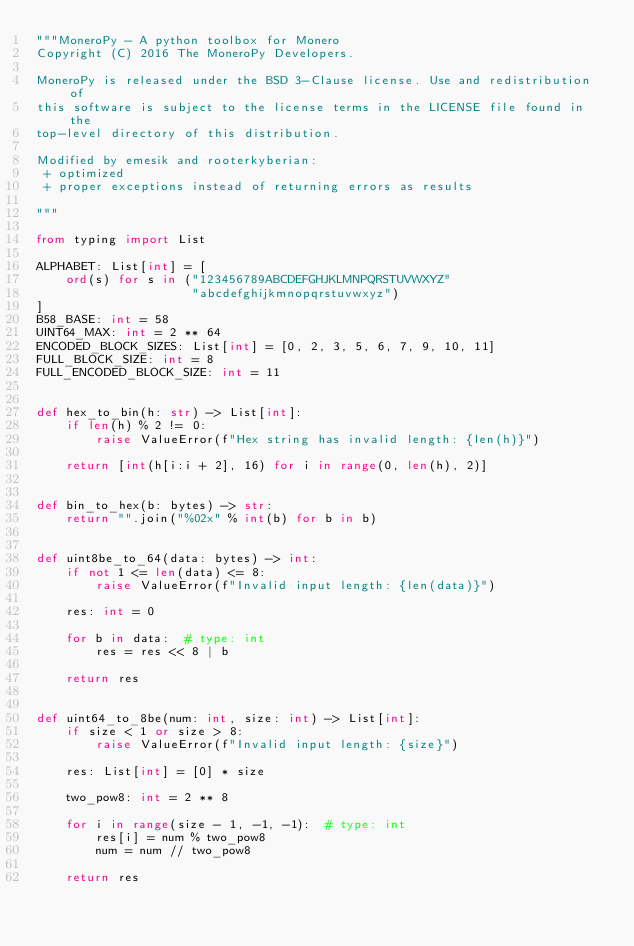<code> <loc_0><loc_0><loc_500><loc_500><_Python_>"""MoneroPy - A python toolbox for Monero
Copyright (C) 2016 The MoneroPy Developers.

MoneroPy is released under the BSD 3-Clause license. Use and redistribution of
this software is subject to the license terms in the LICENSE file found in the
top-level directory of this distribution.

Modified by emesik and rooterkyberian:
 + optimized
 + proper exceptions instead of returning errors as results

"""

from typing import List

ALPHABET: List[int] = [
    ord(s) for s in ("123456789ABCDEFGHJKLMNPQRSTUVWXYZ"
                     "abcdefghijkmnopqrstuvwxyz")
]
B58_BASE: int = 58
UINT64_MAX: int = 2 ** 64
ENCODED_BLOCK_SIZES: List[int] = [0, 2, 3, 5, 6, 7, 9, 10, 11]
FULL_BLOCK_SIZE: int = 8
FULL_ENCODED_BLOCK_SIZE: int = 11


def hex_to_bin(h: str) -> List[int]:
    if len(h) % 2 != 0:
        raise ValueError(f"Hex string has invalid length: {len(h)}")

    return [int(h[i:i + 2], 16) for i in range(0, len(h), 2)]


def bin_to_hex(b: bytes) -> str:
    return "".join("%02x" % int(b) for b in b)


def uint8be_to_64(data: bytes) -> int:
    if not 1 <= len(data) <= 8:
        raise ValueError(f"Invalid input length: {len(data)}")

    res: int = 0

    for b in data:  # type: int
        res = res << 8 | b

    return res


def uint64_to_8be(num: int, size: int) -> List[int]:
    if size < 1 or size > 8:
        raise ValueError(f"Invalid input length: {size}")

    res: List[int] = [0] * size

    two_pow8: int = 2 ** 8

    for i in range(size - 1, -1, -1):  # type: int
        res[i] = num % two_pow8
        num = num // two_pow8

    return res

</code> 